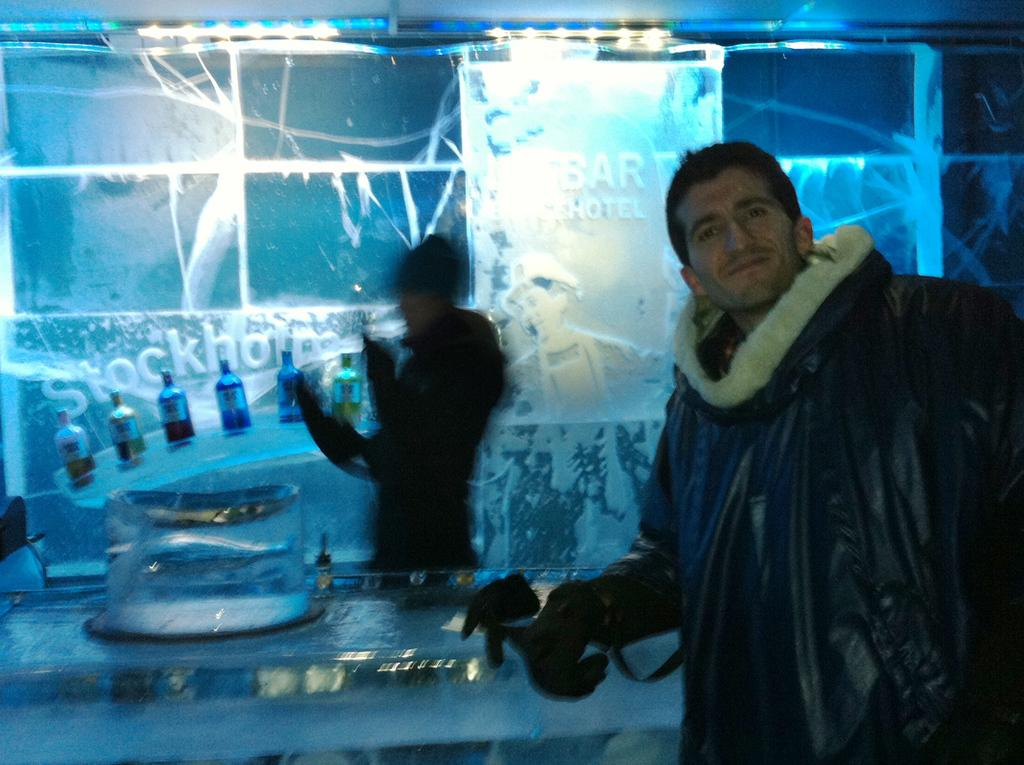How many people are in the image? There are two people standing in the image. What are the people wearing? The people are wearing clothes and gloves. What can be seen in the background of the image? There are bottles visible in the image, and there is an ice bar. What type of lighting is present in the image? There are lights in the image. What type of wax is being used to create the ice bar in the image? There is no wax present in the image; the ice bar is made of ice. What is the weather like in the image? The provided facts do not mention the weather, so it cannot be determined from the image. 